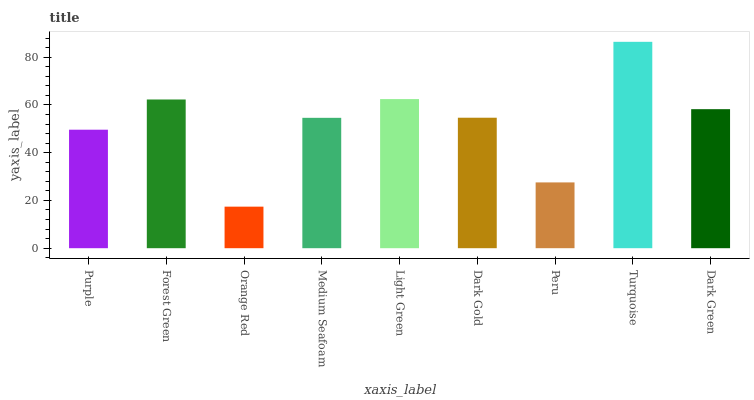Is Orange Red the minimum?
Answer yes or no. Yes. Is Turquoise the maximum?
Answer yes or no. Yes. Is Forest Green the minimum?
Answer yes or no. No. Is Forest Green the maximum?
Answer yes or no. No. Is Forest Green greater than Purple?
Answer yes or no. Yes. Is Purple less than Forest Green?
Answer yes or no. Yes. Is Purple greater than Forest Green?
Answer yes or no. No. Is Forest Green less than Purple?
Answer yes or no. No. Is Dark Gold the high median?
Answer yes or no. Yes. Is Dark Gold the low median?
Answer yes or no. Yes. Is Dark Green the high median?
Answer yes or no. No. Is Peru the low median?
Answer yes or no. No. 